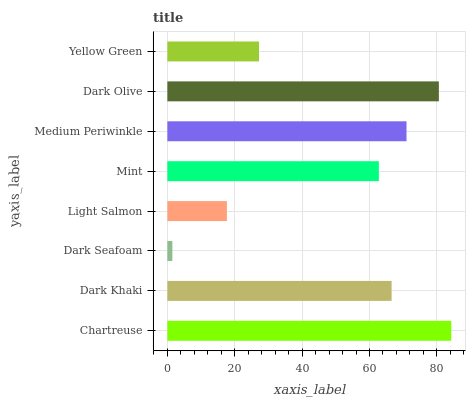Is Dark Seafoam the minimum?
Answer yes or no. Yes. Is Chartreuse the maximum?
Answer yes or no. Yes. Is Dark Khaki the minimum?
Answer yes or no. No. Is Dark Khaki the maximum?
Answer yes or no. No. Is Chartreuse greater than Dark Khaki?
Answer yes or no. Yes. Is Dark Khaki less than Chartreuse?
Answer yes or no. Yes. Is Dark Khaki greater than Chartreuse?
Answer yes or no. No. Is Chartreuse less than Dark Khaki?
Answer yes or no. No. Is Dark Khaki the high median?
Answer yes or no. Yes. Is Mint the low median?
Answer yes or no. Yes. Is Mint the high median?
Answer yes or no. No. Is Medium Periwinkle the low median?
Answer yes or no. No. 